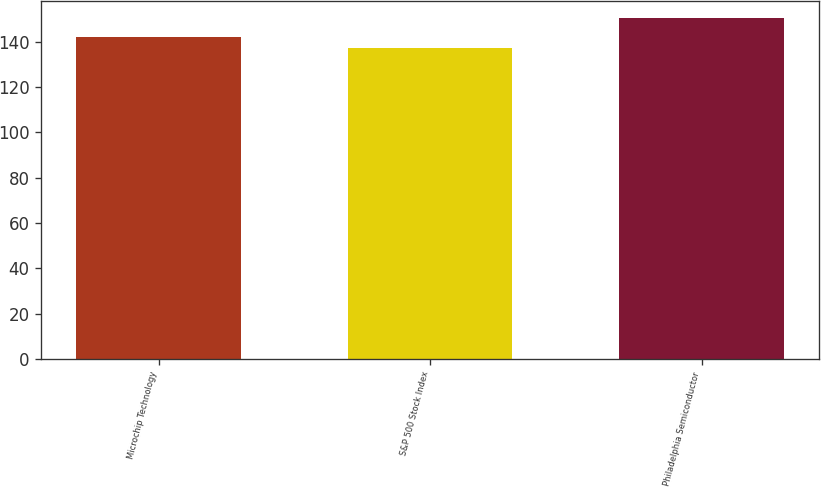<chart> <loc_0><loc_0><loc_500><loc_500><bar_chart><fcel>Microchip Technology<fcel>S&P 500 Stock Index<fcel>Philadelphia Semiconductor<nl><fcel>141.94<fcel>137.37<fcel>150.41<nl></chart> 